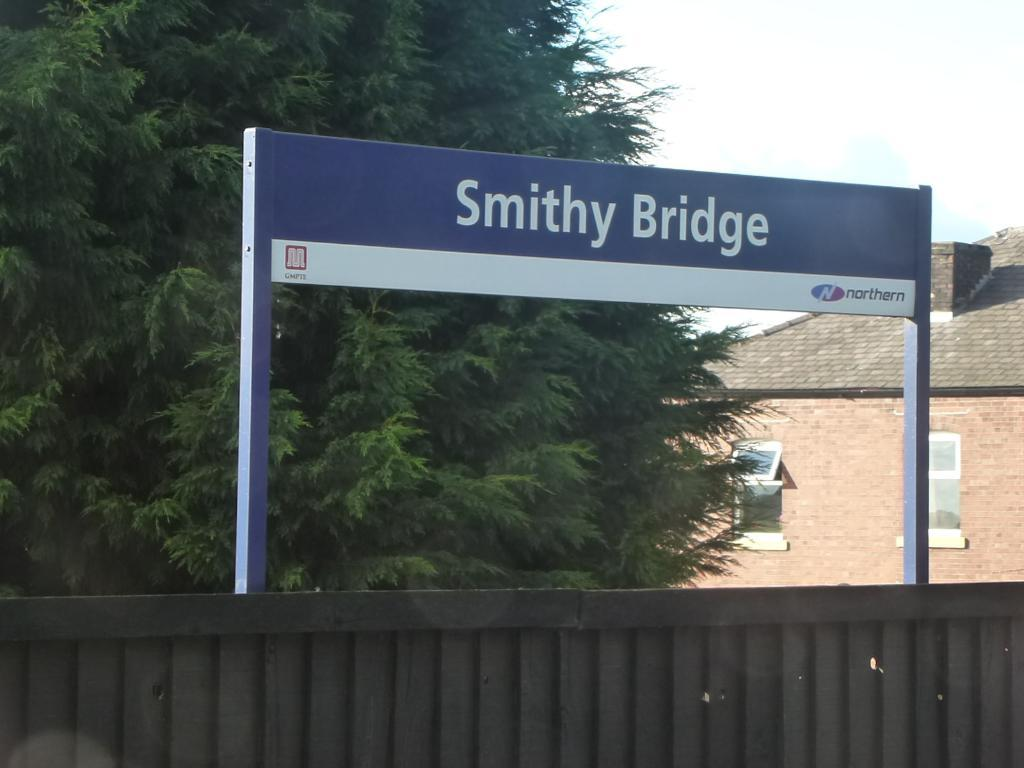What type of structure can be seen in the image? There is a wall in the image. What is attached to the wall? There is a name board in the image. What type of vegetation is present in the image? There is a tree in the image. What type of building can be seen in the image? There is a building with windows in the image. What can be seen in the background of the image? The sky is visible in the background of the image. How many loaves of bread are hanging from the tree in the image? There are no loaves of bread present in the image; it features a tree and other structures. What type of island can be seen in the background of the image? There is no island present in the image; it features a building, a wall, a tree, and the sky. 